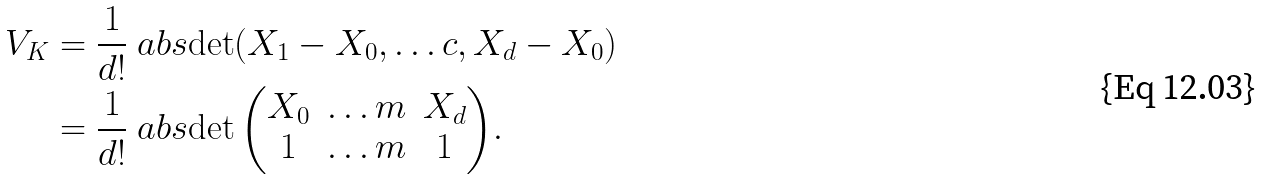Convert formula to latex. <formula><loc_0><loc_0><loc_500><loc_500>V _ { K } & = \frac { 1 } { d ! } \ a b s { \det ( X _ { 1 } - X _ { 0 } , \dots c , X _ { d } - X _ { 0 } ) } \\ & = \frac { 1 } { d ! } \ a b s { \det \begin{pmatrix} X _ { 0 } & \dots m & X _ { d } \\ 1 & \dots m & 1 \end{pmatrix} } .</formula> 